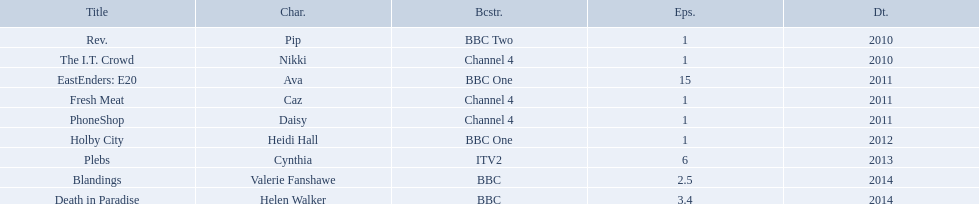Which characters were featured in more then one episode? Ava, Cynthia, Valerie Fanshawe, Helen Walker. Could you parse the entire table? {'header': ['Title', 'Char.', 'Bcstr.', 'Eps.', 'Dt.'], 'rows': [['Rev.', 'Pip', 'BBC Two', '1', '2010'], ['The I.T. Crowd', 'Nikki', 'Channel 4', '1', '2010'], ['EastEnders: E20', 'Ava', 'BBC One', '15', '2011'], ['Fresh Meat', 'Caz', 'Channel 4', '1', '2011'], ['PhoneShop', 'Daisy', 'Channel 4', '1', '2011'], ['Holby City', 'Heidi Hall', 'BBC One', '1', '2012'], ['Plebs', 'Cynthia', 'ITV2', '6', '2013'], ['Blandings', 'Valerie Fanshawe', 'BBC', '2.5', '2014'], ['Death in Paradise', 'Helen Walker', 'BBC', '3.4', '2014']]} Which of these were not in 2014? Ava, Cynthia. Which one of those was not on a bbc broadcaster? Cynthia. What roles did she play? Pip, Nikki, Ava, Caz, Daisy, Heidi Hall, Cynthia, Valerie Fanshawe, Helen Walker. On which broadcasters? BBC Two, Channel 4, BBC One, Channel 4, Channel 4, BBC One, ITV2, BBC, BBC. Which roles did she play for itv2? Cynthia. 